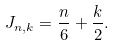Convert formula to latex. <formula><loc_0><loc_0><loc_500><loc_500>J _ { n , k } = \frac { n } { 6 } + \frac { k } { 2 } .</formula> 